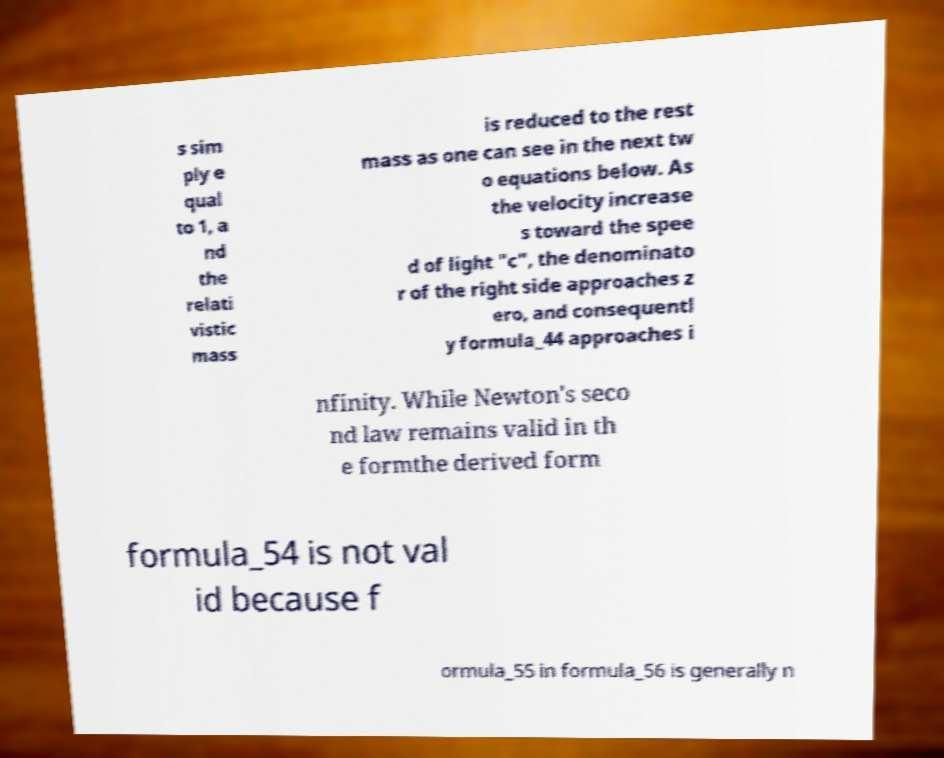I need the written content from this picture converted into text. Can you do that? s sim ply e qual to 1, a nd the relati vistic mass is reduced to the rest mass as one can see in the next tw o equations below. As the velocity increase s toward the spee d of light "c", the denominato r of the right side approaches z ero, and consequentl y formula_44 approaches i nfinity. While Newton's seco nd law remains valid in th e formthe derived form formula_54 is not val id because f ormula_55 in formula_56 is generally n 